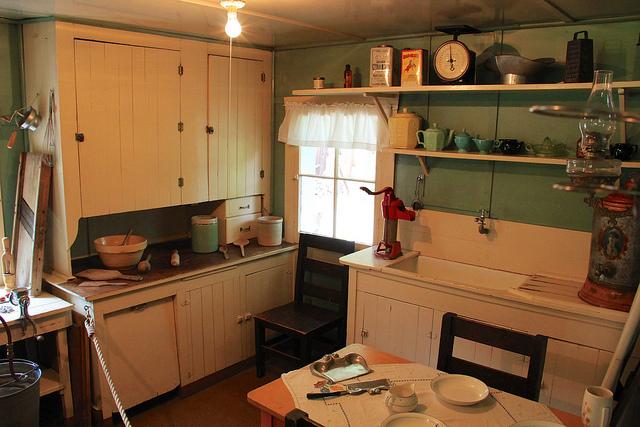What room was the picture taken?
Answer briefly. Kitchen. What kind of mixer on the counter?
Give a very brief answer. Blender. How many chairs are there?
Short answer required. 2. What is the red pump for?
Concise answer only. Water. How many stove does this kitchen have?
Answer briefly. 0. What time is it according to the clock on the wall?
Be succinct. No clock. 